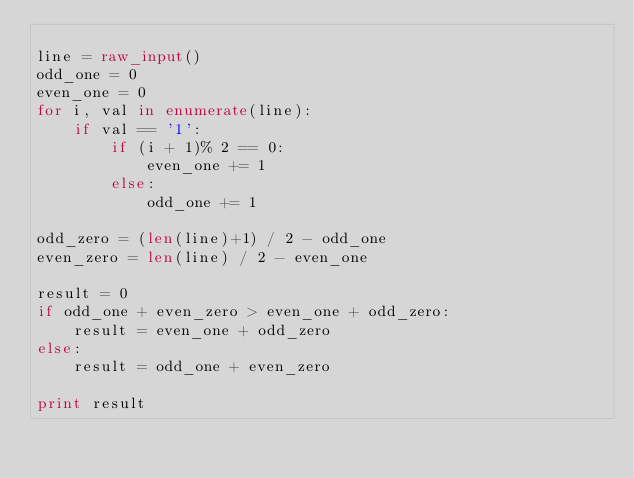<code> <loc_0><loc_0><loc_500><loc_500><_Python_>
line = raw_input()
odd_one = 0
even_one = 0
for i, val in enumerate(line):
    if val == '1':
        if (i + 1)% 2 == 0:
            even_one += 1
        else:
            odd_one += 1

odd_zero = (len(line)+1) / 2 - odd_one
even_zero = len(line) / 2 - even_one

result = 0
if odd_one + even_zero > even_one + odd_zero:
    result = even_one + odd_zero
else:
    result = odd_one + even_zero

print result

</code> 